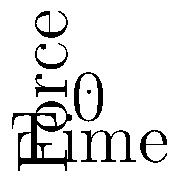As a social media user interested in politics and biomechanics, you come across a post about the forces acting on a runner's leg during different phases of the gait cycle. Which force reaches its peak magnitude during the mid-stance phase, and what is its primary function at this point? To answer this question, let's analyze the forces acting on a runner's leg during the gait cycle:

1. Ground Reaction Force (GRF):
   - Represented by the blue line in the graph
   - Peaks during the mid-stance phase
   - Function: Counteracts the body's weight and provides support

2. Muscle Force:
   - Represented by the red line in the graph
   - Increases during early stance and remains relatively high during mid-stance
   - Function: Stabilizes joints and controls leg movement

3. Gravitational Force:
   - Represented by the green line in the graph
   - Remains constant throughout the gait cycle
   - Function: Pulls the body downward

Analyzing the graph, we can see that the Ground Reaction Force (blue line) reaches its peak during the mid-stance phase. At this point, the runner's body weight is fully supported by a single leg, and the center of mass is directly over the foot.

The primary function of the Ground Reaction Force during mid-stance is to:
1. Support the body weight
2. Counteract the downward pull of gravity
3. Provide a stable base for propulsion in the next phase (toe-off)

This force is crucial for maintaining balance and allowing the runner to progress forward in their gait cycle.
Answer: Ground Reaction Force; support body weight and counteract gravity 